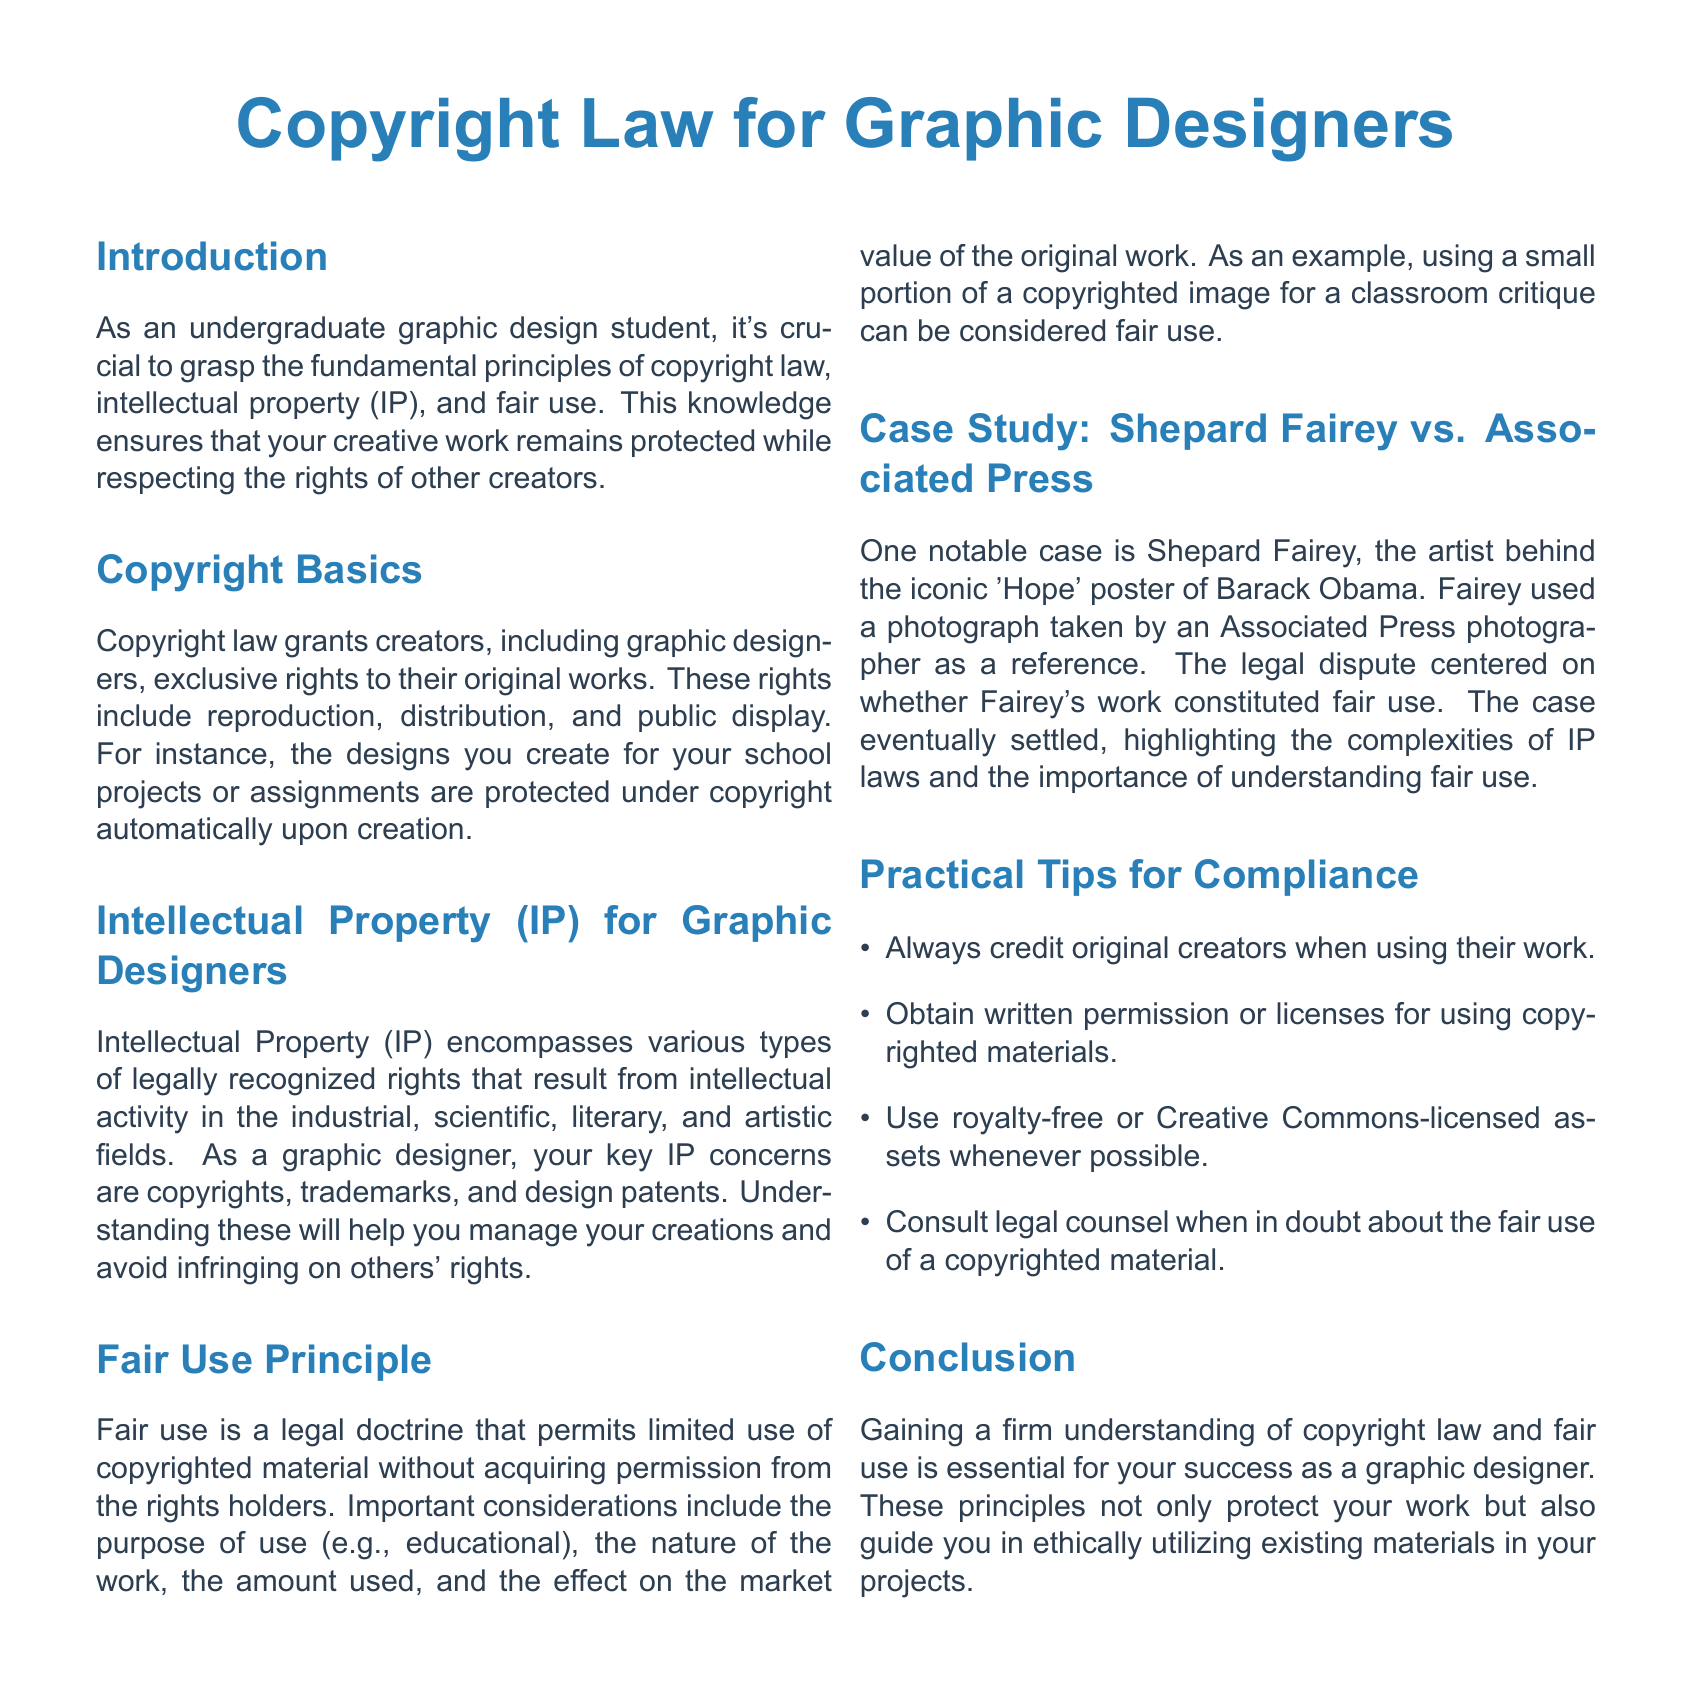What is the title of the document? The title of the document is presented at the beginning section.
Answer: Copyright Law for Graphic Designers What legal doctrine permits limited use of copyrighted material? The document describes a specific legal doctrine related to the use of copyrighted material.
Answer: Fair use Who was the artist behind the 'Hope' poster? The document provides the name of the artist involved in the noted case study.
Answer: Shepard Fairey What are the three key IP concerns for graphic designers mentioned? The document lists concerns specifically related to intellectual property for graphic designers.
Answer: Copyrights, trademarks, and design patents What should you do when in doubt about fair use? The document provides advice concerning uncertainties in fair use of copyrighted materials.
Answer: Consult legal counsel What are the first three practical tips for compliance given in the document? The document outlines practical tips for compliance with copyright law, including actions to take.
Answer: Credit original creators, obtain written permission, use royalty-free assets 